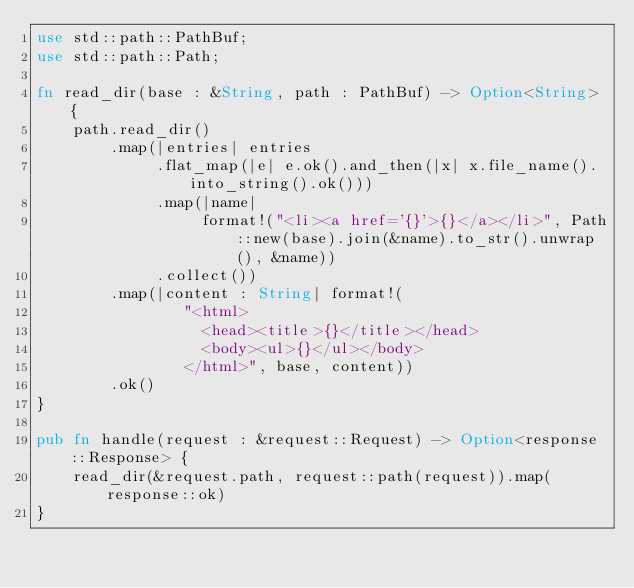Convert code to text. <code><loc_0><loc_0><loc_500><loc_500><_Rust_>use std::path::PathBuf;
use std::path::Path;

fn read_dir(base : &String, path : PathBuf) -> Option<String> {
    path.read_dir()
        .map(|entries| entries
             .flat_map(|e| e.ok().and_then(|x| x.file_name().into_string().ok()))
             .map(|name|
                  format!("<li><a href='{}'>{}</a></li>", Path::new(base).join(&name).to_str().unwrap(), &name))
             .collect())
        .map(|content : String| format!(
                "<html>
                  <head><title>{}</title></head>
                  <body><ul>{}</ul></body>
                </html>", base, content))
        .ok()
}

pub fn handle(request : &request::Request) -> Option<response::Response> {
    read_dir(&request.path, request::path(request)).map(response::ok)
}
</code> 